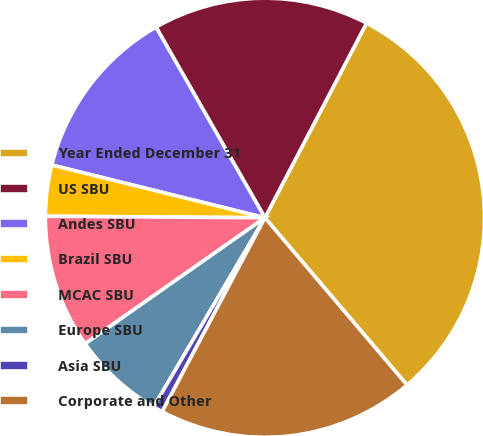Convert chart. <chart><loc_0><loc_0><loc_500><loc_500><pie_chart><fcel>Year Ended December 31<fcel>US SBU<fcel>Andes SBU<fcel>Brazil SBU<fcel>MCAC SBU<fcel>Europe SBU<fcel>Asia SBU<fcel>Corporate and Other<nl><fcel>31.13%<fcel>15.92%<fcel>12.88%<fcel>3.75%<fcel>9.84%<fcel>6.8%<fcel>0.71%<fcel>18.96%<nl></chart> 